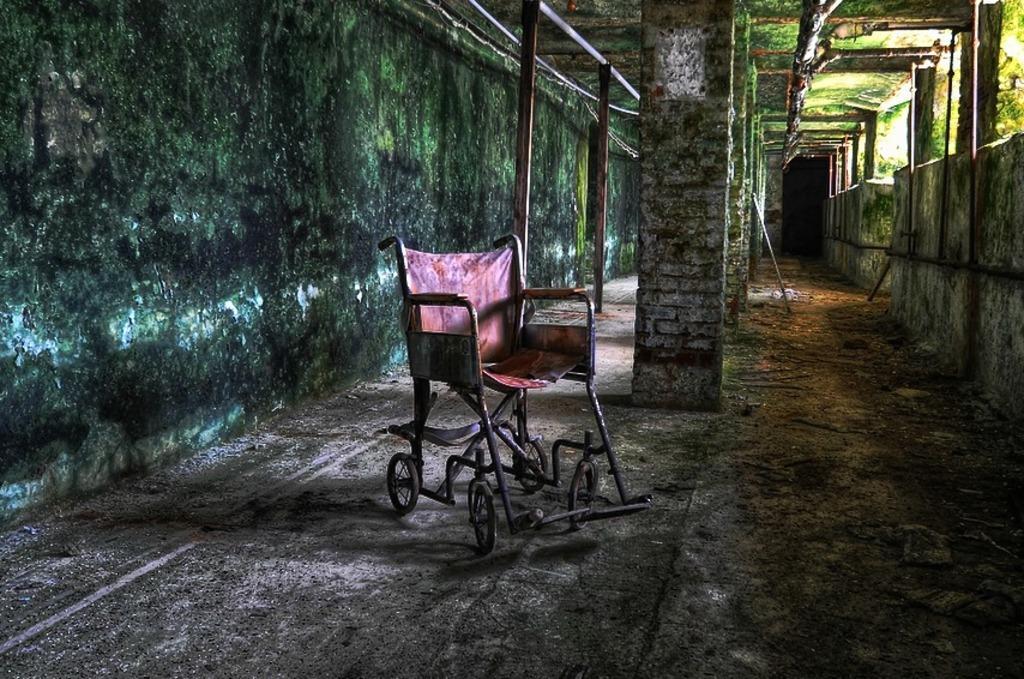In one or two sentences, can you explain what this image depicts? In this image, we can see a chair. We can see the ground with some objects. We can see some pillars. We can see the wall with algae. There are a few poles. We can see the roof. 